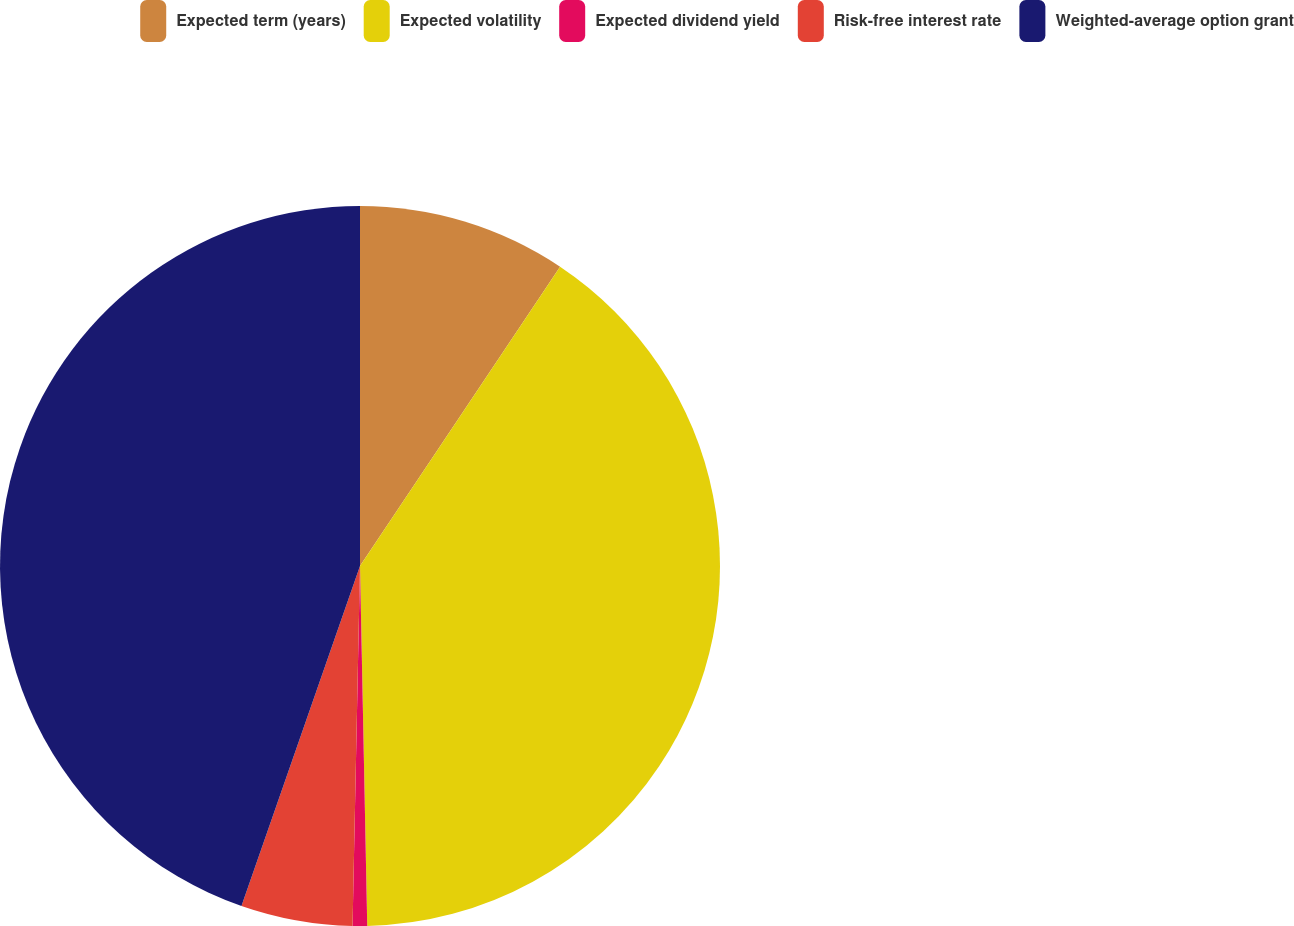Convert chart to OTSL. <chart><loc_0><loc_0><loc_500><loc_500><pie_chart><fcel>Expected term (years)<fcel>Expected volatility<fcel>Expected dividend yield<fcel>Risk-free interest rate<fcel>Weighted-average option grant<nl><fcel>9.38%<fcel>40.3%<fcel>0.65%<fcel>5.01%<fcel>44.66%<nl></chart> 